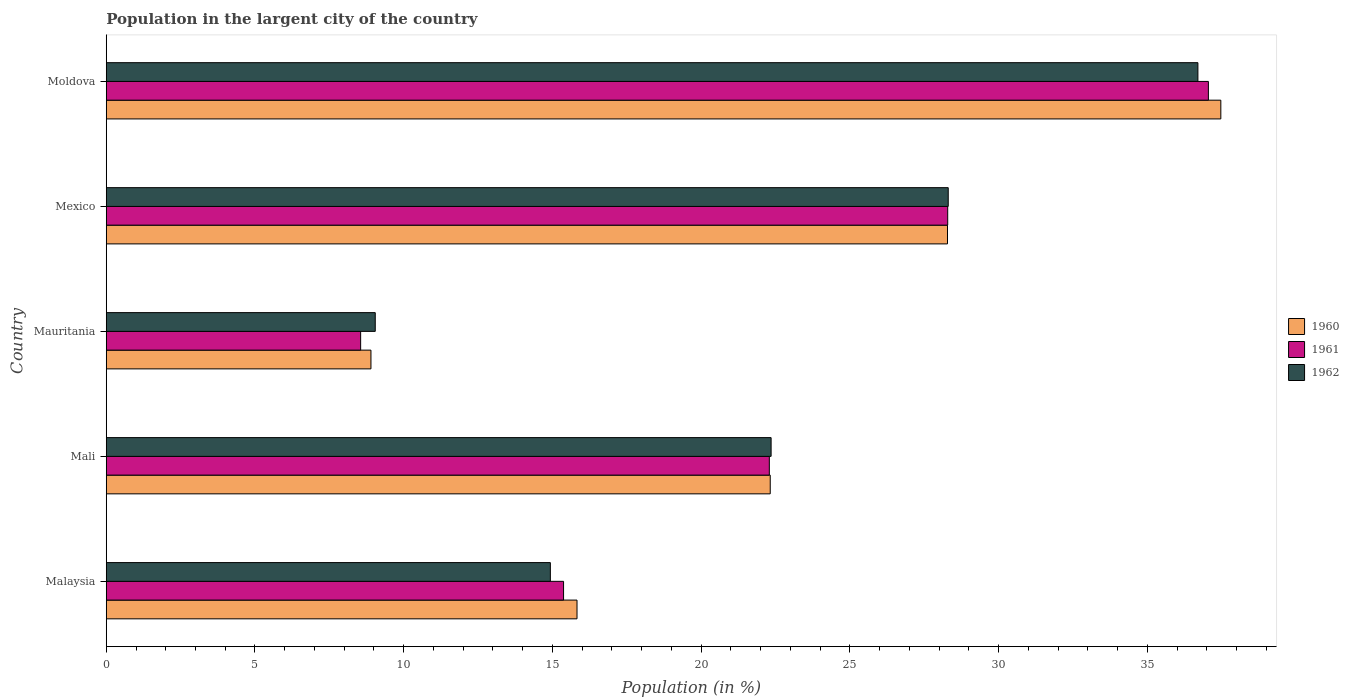How many different coloured bars are there?
Your answer should be very brief. 3. How many groups of bars are there?
Your answer should be very brief. 5. Are the number of bars per tick equal to the number of legend labels?
Give a very brief answer. Yes. Are the number of bars on each tick of the Y-axis equal?
Ensure brevity in your answer.  Yes. How many bars are there on the 5th tick from the top?
Your response must be concise. 3. What is the label of the 4th group of bars from the top?
Your answer should be compact. Mali. What is the percentage of population in the largent city in 1960 in Mali?
Your answer should be very brief. 22.32. Across all countries, what is the maximum percentage of population in the largent city in 1962?
Your answer should be very brief. 36.7. Across all countries, what is the minimum percentage of population in the largent city in 1962?
Give a very brief answer. 9.04. In which country was the percentage of population in the largent city in 1961 maximum?
Your answer should be compact. Moldova. In which country was the percentage of population in the largent city in 1961 minimum?
Keep it short and to the point. Mauritania. What is the total percentage of population in the largent city in 1961 in the graph?
Provide a succinct answer. 111.55. What is the difference between the percentage of population in the largent city in 1961 in Mali and that in Mauritania?
Your answer should be compact. 13.74. What is the difference between the percentage of population in the largent city in 1960 in Malaysia and the percentage of population in the largent city in 1961 in Mali?
Provide a short and direct response. -6.46. What is the average percentage of population in the largent city in 1962 per country?
Your response must be concise. 22.27. What is the difference between the percentage of population in the largent city in 1962 and percentage of population in the largent city in 1960 in Moldova?
Your answer should be compact. -0.77. What is the ratio of the percentage of population in the largent city in 1961 in Mali to that in Mauritania?
Offer a terse response. 2.61. Is the difference between the percentage of population in the largent city in 1962 in Mali and Mauritania greater than the difference between the percentage of population in the largent city in 1960 in Mali and Mauritania?
Offer a terse response. No. What is the difference between the highest and the second highest percentage of population in the largent city in 1960?
Your answer should be compact. 9.19. What is the difference between the highest and the lowest percentage of population in the largent city in 1961?
Provide a short and direct response. 28.5. In how many countries, is the percentage of population in the largent city in 1962 greater than the average percentage of population in the largent city in 1962 taken over all countries?
Keep it short and to the point. 3. What does the 3rd bar from the top in Moldova represents?
Give a very brief answer. 1960. How many countries are there in the graph?
Your answer should be compact. 5. Does the graph contain grids?
Your response must be concise. No. How many legend labels are there?
Your answer should be compact. 3. How are the legend labels stacked?
Offer a terse response. Vertical. What is the title of the graph?
Make the answer very short. Population in the largent city of the country. Does "1993" appear as one of the legend labels in the graph?
Ensure brevity in your answer.  No. What is the label or title of the X-axis?
Provide a succinct answer. Population (in %). What is the Population (in %) in 1960 in Malaysia?
Provide a short and direct response. 15.83. What is the Population (in %) of 1961 in Malaysia?
Offer a terse response. 15.37. What is the Population (in %) of 1962 in Malaysia?
Provide a short and direct response. 14.93. What is the Population (in %) in 1960 in Mali?
Keep it short and to the point. 22.32. What is the Population (in %) of 1961 in Mali?
Offer a terse response. 22.29. What is the Population (in %) of 1962 in Mali?
Give a very brief answer. 22.35. What is the Population (in %) of 1960 in Mauritania?
Ensure brevity in your answer.  8.9. What is the Population (in %) in 1961 in Mauritania?
Your answer should be very brief. 8.55. What is the Population (in %) of 1962 in Mauritania?
Provide a short and direct response. 9.04. What is the Population (in %) in 1960 in Mexico?
Ensure brevity in your answer.  28.28. What is the Population (in %) of 1961 in Mexico?
Your response must be concise. 28.29. What is the Population (in %) of 1962 in Mexico?
Keep it short and to the point. 28.31. What is the Population (in %) in 1960 in Moldova?
Provide a succinct answer. 37.47. What is the Population (in %) in 1961 in Moldova?
Offer a very short reply. 37.05. What is the Population (in %) in 1962 in Moldova?
Make the answer very short. 36.7. Across all countries, what is the maximum Population (in %) in 1960?
Give a very brief answer. 37.47. Across all countries, what is the maximum Population (in %) in 1961?
Give a very brief answer. 37.05. Across all countries, what is the maximum Population (in %) of 1962?
Your answer should be very brief. 36.7. Across all countries, what is the minimum Population (in %) of 1960?
Provide a short and direct response. 8.9. Across all countries, what is the minimum Population (in %) in 1961?
Provide a succinct answer. 8.55. Across all countries, what is the minimum Population (in %) in 1962?
Provide a succinct answer. 9.04. What is the total Population (in %) of 1960 in the graph?
Give a very brief answer. 112.8. What is the total Population (in %) of 1961 in the graph?
Offer a very short reply. 111.55. What is the total Population (in %) in 1962 in the graph?
Ensure brevity in your answer.  111.33. What is the difference between the Population (in %) of 1960 in Malaysia and that in Mali?
Provide a succinct answer. -6.5. What is the difference between the Population (in %) in 1961 in Malaysia and that in Mali?
Offer a very short reply. -6.92. What is the difference between the Population (in %) of 1962 in Malaysia and that in Mali?
Make the answer very short. -7.42. What is the difference between the Population (in %) in 1960 in Malaysia and that in Mauritania?
Provide a short and direct response. 6.93. What is the difference between the Population (in %) in 1961 in Malaysia and that in Mauritania?
Your response must be concise. 6.82. What is the difference between the Population (in %) of 1962 in Malaysia and that in Mauritania?
Offer a very short reply. 5.89. What is the difference between the Population (in %) in 1960 in Malaysia and that in Mexico?
Offer a very short reply. -12.45. What is the difference between the Population (in %) of 1961 in Malaysia and that in Mexico?
Provide a succinct answer. -12.91. What is the difference between the Population (in %) of 1962 in Malaysia and that in Mexico?
Offer a terse response. -13.38. What is the difference between the Population (in %) of 1960 in Malaysia and that in Moldova?
Your answer should be very brief. -21.64. What is the difference between the Population (in %) of 1961 in Malaysia and that in Moldova?
Your answer should be very brief. -21.68. What is the difference between the Population (in %) of 1962 in Malaysia and that in Moldova?
Keep it short and to the point. -21.77. What is the difference between the Population (in %) of 1960 in Mali and that in Mauritania?
Give a very brief answer. 13.42. What is the difference between the Population (in %) in 1961 in Mali and that in Mauritania?
Ensure brevity in your answer.  13.74. What is the difference between the Population (in %) in 1962 in Mali and that in Mauritania?
Provide a short and direct response. 13.31. What is the difference between the Population (in %) in 1960 in Mali and that in Mexico?
Ensure brevity in your answer.  -5.96. What is the difference between the Population (in %) of 1961 in Mali and that in Mexico?
Your answer should be compact. -6. What is the difference between the Population (in %) in 1962 in Mali and that in Mexico?
Provide a short and direct response. -5.95. What is the difference between the Population (in %) of 1960 in Mali and that in Moldova?
Ensure brevity in your answer.  -15.15. What is the difference between the Population (in %) of 1961 in Mali and that in Moldova?
Give a very brief answer. -14.76. What is the difference between the Population (in %) of 1962 in Mali and that in Moldova?
Offer a very short reply. -14.35. What is the difference between the Population (in %) in 1960 in Mauritania and that in Mexico?
Your answer should be compact. -19.38. What is the difference between the Population (in %) in 1961 in Mauritania and that in Mexico?
Ensure brevity in your answer.  -19.73. What is the difference between the Population (in %) in 1962 in Mauritania and that in Mexico?
Provide a short and direct response. -19.26. What is the difference between the Population (in %) in 1960 in Mauritania and that in Moldova?
Keep it short and to the point. -28.57. What is the difference between the Population (in %) of 1961 in Mauritania and that in Moldova?
Your answer should be compact. -28.5. What is the difference between the Population (in %) in 1962 in Mauritania and that in Moldova?
Give a very brief answer. -27.66. What is the difference between the Population (in %) of 1960 in Mexico and that in Moldova?
Your answer should be very brief. -9.19. What is the difference between the Population (in %) in 1961 in Mexico and that in Moldova?
Make the answer very short. -8.76. What is the difference between the Population (in %) of 1962 in Mexico and that in Moldova?
Your response must be concise. -8.39. What is the difference between the Population (in %) of 1960 in Malaysia and the Population (in %) of 1961 in Mali?
Keep it short and to the point. -6.46. What is the difference between the Population (in %) in 1960 in Malaysia and the Population (in %) in 1962 in Mali?
Keep it short and to the point. -6.52. What is the difference between the Population (in %) of 1961 in Malaysia and the Population (in %) of 1962 in Mali?
Provide a succinct answer. -6.98. What is the difference between the Population (in %) in 1960 in Malaysia and the Population (in %) in 1961 in Mauritania?
Your answer should be compact. 7.27. What is the difference between the Population (in %) in 1960 in Malaysia and the Population (in %) in 1962 in Mauritania?
Offer a terse response. 6.78. What is the difference between the Population (in %) in 1961 in Malaysia and the Population (in %) in 1962 in Mauritania?
Ensure brevity in your answer.  6.33. What is the difference between the Population (in %) of 1960 in Malaysia and the Population (in %) of 1961 in Mexico?
Make the answer very short. -12.46. What is the difference between the Population (in %) in 1960 in Malaysia and the Population (in %) in 1962 in Mexico?
Provide a short and direct response. -12.48. What is the difference between the Population (in %) in 1961 in Malaysia and the Population (in %) in 1962 in Mexico?
Offer a terse response. -12.93. What is the difference between the Population (in %) of 1960 in Malaysia and the Population (in %) of 1961 in Moldova?
Keep it short and to the point. -21.22. What is the difference between the Population (in %) of 1960 in Malaysia and the Population (in %) of 1962 in Moldova?
Offer a very short reply. -20.87. What is the difference between the Population (in %) of 1961 in Malaysia and the Population (in %) of 1962 in Moldova?
Ensure brevity in your answer.  -21.32. What is the difference between the Population (in %) in 1960 in Mali and the Population (in %) in 1961 in Mauritania?
Your answer should be compact. 13.77. What is the difference between the Population (in %) in 1960 in Mali and the Population (in %) in 1962 in Mauritania?
Offer a terse response. 13.28. What is the difference between the Population (in %) of 1961 in Mali and the Population (in %) of 1962 in Mauritania?
Your response must be concise. 13.25. What is the difference between the Population (in %) of 1960 in Mali and the Population (in %) of 1961 in Mexico?
Offer a terse response. -5.97. What is the difference between the Population (in %) in 1960 in Mali and the Population (in %) in 1962 in Mexico?
Make the answer very short. -5.98. What is the difference between the Population (in %) of 1961 in Mali and the Population (in %) of 1962 in Mexico?
Offer a very short reply. -6.01. What is the difference between the Population (in %) in 1960 in Mali and the Population (in %) in 1961 in Moldova?
Provide a short and direct response. -14.73. What is the difference between the Population (in %) of 1960 in Mali and the Population (in %) of 1962 in Moldova?
Your answer should be compact. -14.38. What is the difference between the Population (in %) in 1961 in Mali and the Population (in %) in 1962 in Moldova?
Keep it short and to the point. -14.41. What is the difference between the Population (in %) in 1960 in Mauritania and the Population (in %) in 1961 in Mexico?
Offer a very short reply. -19.39. What is the difference between the Population (in %) in 1960 in Mauritania and the Population (in %) in 1962 in Mexico?
Provide a succinct answer. -19.41. What is the difference between the Population (in %) in 1961 in Mauritania and the Population (in %) in 1962 in Mexico?
Your response must be concise. -19.75. What is the difference between the Population (in %) of 1960 in Mauritania and the Population (in %) of 1961 in Moldova?
Your answer should be very brief. -28.15. What is the difference between the Population (in %) in 1960 in Mauritania and the Population (in %) in 1962 in Moldova?
Offer a terse response. -27.8. What is the difference between the Population (in %) of 1961 in Mauritania and the Population (in %) of 1962 in Moldova?
Offer a terse response. -28.15. What is the difference between the Population (in %) in 1960 in Mexico and the Population (in %) in 1961 in Moldova?
Keep it short and to the point. -8.77. What is the difference between the Population (in %) in 1960 in Mexico and the Population (in %) in 1962 in Moldova?
Keep it short and to the point. -8.42. What is the difference between the Population (in %) of 1961 in Mexico and the Population (in %) of 1962 in Moldova?
Your answer should be compact. -8.41. What is the average Population (in %) of 1960 per country?
Your response must be concise. 22.56. What is the average Population (in %) in 1961 per country?
Provide a succinct answer. 22.31. What is the average Population (in %) in 1962 per country?
Ensure brevity in your answer.  22.27. What is the difference between the Population (in %) in 1960 and Population (in %) in 1961 in Malaysia?
Your answer should be very brief. 0.45. What is the difference between the Population (in %) of 1960 and Population (in %) of 1962 in Malaysia?
Provide a succinct answer. 0.9. What is the difference between the Population (in %) of 1961 and Population (in %) of 1962 in Malaysia?
Your answer should be very brief. 0.44. What is the difference between the Population (in %) in 1960 and Population (in %) in 1961 in Mali?
Your response must be concise. 0.03. What is the difference between the Population (in %) in 1960 and Population (in %) in 1962 in Mali?
Provide a succinct answer. -0.03. What is the difference between the Population (in %) of 1961 and Population (in %) of 1962 in Mali?
Offer a very short reply. -0.06. What is the difference between the Population (in %) in 1960 and Population (in %) in 1961 in Mauritania?
Offer a very short reply. 0.35. What is the difference between the Population (in %) in 1960 and Population (in %) in 1962 in Mauritania?
Provide a short and direct response. -0.14. What is the difference between the Population (in %) in 1961 and Population (in %) in 1962 in Mauritania?
Provide a short and direct response. -0.49. What is the difference between the Population (in %) of 1960 and Population (in %) of 1961 in Mexico?
Give a very brief answer. -0.01. What is the difference between the Population (in %) in 1960 and Population (in %) in 1962 in Mexico?
Your answer should be very brief. -0.02. What is the difference between the Population (in %) in 1961 and Population (in %) in 1962 in Mexico?
Make the answer very short. -0.02. What is the difference between the Population (in %) of 1960 and Population (in %) of 1961 in Moldova?
Make the answer very short. 0.42. What is the difference between the Population (in %) of 1960 and Population (in %) of 1962 in Moldova?
Keep it short and to the point. 0.77. What is the difference between the Population (in %) of 1961 and Population (in %) of 1962 in Moldova?
Give a very brief answer. 0.35. What is the ratio of the Population (in %) of 1960 in Malaysia to that in Mali?
Your response must be concise. 0.71. What is the ratio of the Population (in %) in 1961 in Malaysia to that in Mali?
Your response must be concise. 0.69. What is the ratio of the Population (in %) of 1962 in Malaysia to that in Mali?
Offer a very short reply. 0.67. What is the ratio of the Population (in %) in 1960 in Malaysia to that in Mauritania?
Keep it short and to the point. 1.78. What is the ratio of the Population (in %) in 1961 in Malaysia to that in Mauritania?
Your answer should be compact. 1.8. What is the ratio of the Population (in %) of 1962 in Malaysia to that in Mauritania?
Offer a very short reply. 1.65. What is the ratio of the Population (in %) of 1960 in Malaysia to that in Mexico?
Give a very brief answer. 0.56. What is the ratio of the Population (in %) of 1961 in Malaysia to that in Mexico?
Your answer should be compact. 0.54. What is the ratio of the Population (in %) in 1962 in Malaysia to that in Mexico?
Ensure brevity in your answer.  0.53. What is the ratio of the Population (in %) in 1960 in Malaysia to that in Moldova?
Keep it short and to the point. 0.42. What is the ratio of the Population (in %) in 1961 in Malaysia to that in Moldova?
Ensure brevity in your answer.  0.41. What is the ratio of the Population (in %) in 1962 in Malaysia to that in Moldova?
Make the answer very short. 0.41. What is the ratio of the Population (in %) in 1960 in Mali to that in Mauritania?
Offer a terse response. 2.51. What is the ratio of the Population (in %) of 1961 in Mali to that in Mauritania?
Your answer should be very brief. 2.61. What is the ratio of the Population (in %) of 1962 in Mali to that in Mauritania?
Offer a terse response. 2.47. What is the ratio of the Population (in %) in 1960 in Mali to that in Mexico?
Provide a succinct answer. 0.79. What is the ratio of the Population (in %) in 1961 in Mali to that in Mexico?
Offer a very short reply. 0.79. What is the ratio of the Population (in %) of 1962 in Mali to that in Mexico?
Give a very brief answer. 0.79. What is the ratio of the Population (in %) in 1960 in Mali to that in Moldova?
Your answer should be very brief. 0.6. What is the ratio of the Population (in %) in 1961 in Mali to that in Moldova?
Keep it short and to the point. 0.6. What is the ratio of the Population (in %) in 1962 in Mali to that in Moldova?
Your answer should be very brief. 0.61. What is the ratio of the Population (in %) of 1960 in Mauritania to that in Mexico?
Your response must be concise. 0.31. What is the ratio of the Population (in %) in 1961 in Mauritania to that in Mexico?
Provide a succinct answer. 0.3. What is the ratio of the Population (in %) of 1962 in Mauritania to that in Mexico?
Your response must be concise. 0.32. What is the ratio of the Population (in %) of 1960 in Mauritania to that in Moldova?
Provide a short and direct response. 0.24. What is the ratio of the Population (in %) in 1961 in Mauritania to that in Moldova?
Provide a succinct answer. 0.23. What is the ratio of the Population (in %) in 1962 in Mauritania to that in Moldova?
Keep it short and to the point. 0.25. What is the ratio of the Population (in %) of 1960 in Mexico to that in Moldova?
Keep it short and to the point. 0.75. What is the ratio of the Population (in %) in 1961 in Mexico to that in Moldova?
Provide a succinct answer. 0.76. What is the ratio of the Population (in %) in 1962 in Mexico to that in Moldova?
Give a very brief answer. 0.77. What is the difference between the highest and the second highest Population (in %) in 1960?
Your answer should be compact. 9.19. What is the difference between the highest and the second highest Population (in %) in 1961?
Your answer should be compact. 8.76. What is the difference between the highest and the second highest Population (in %) of 1962?
Offer a terse response. 8.39. What is the difference between the highest and the lowest Population (in %) of 1960?
Ensure brevity in your answer.  28.57. What is the difference between the highest and the lowest Population (in %) in 1961?
Make the answer very short. 28.5. What is the difference between the highest and the lowest Population (in %) in 1962?
Give a very brief answer. 27.66. 